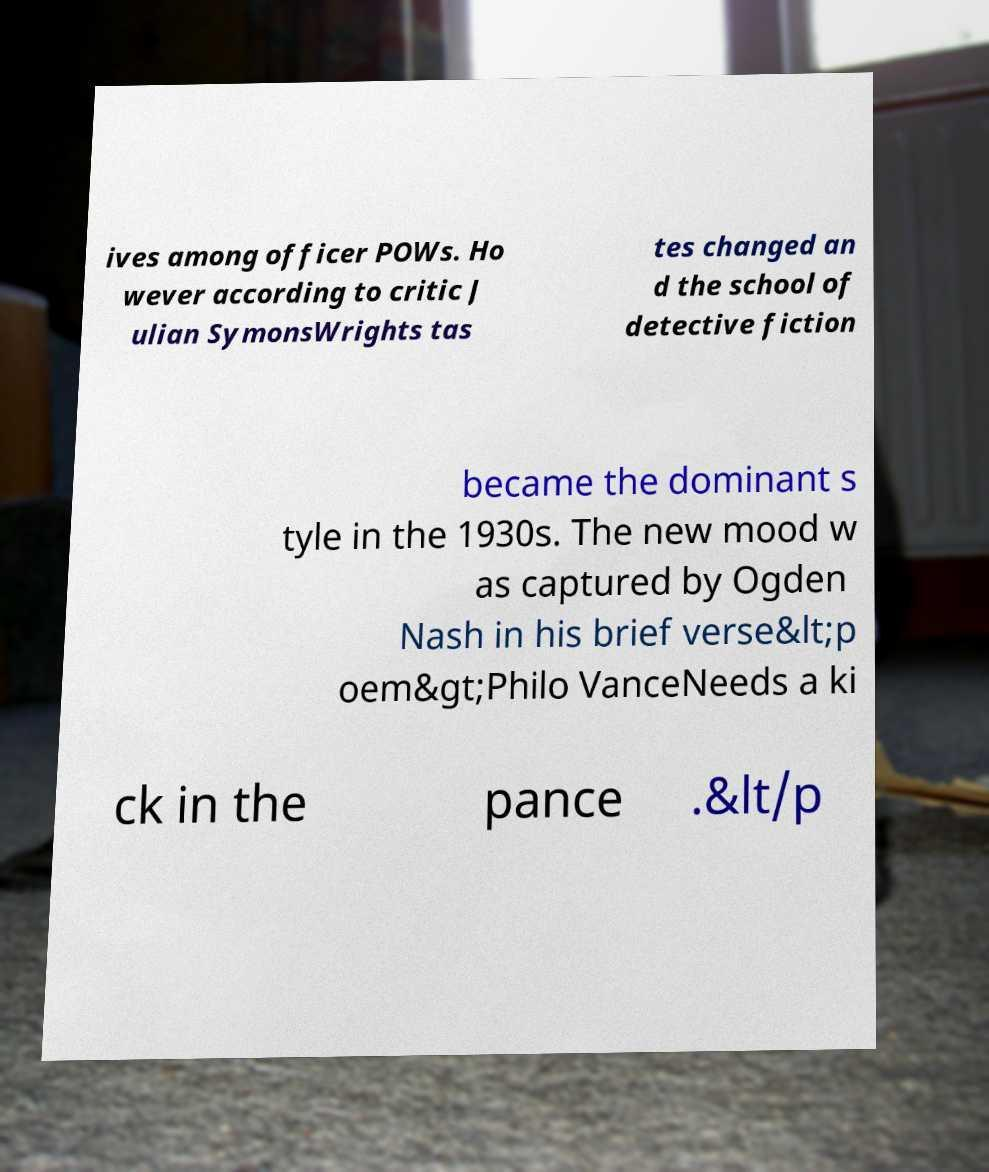Can you read and provide the text displayed in the image?This photo seems to have some interesting text. Can you extract and type it out for me? ives among officer POWs. Ho wever according to critic J ulian SymonsWrights tas tes changed an d the school of detective fiction became the dominant s tyle in the 1930s. The new mood w as captured by Ogden Nash in his brief verse&lt;p oem&gt;Philo VanceNeeds a ki ck in the pance .&lt/p 